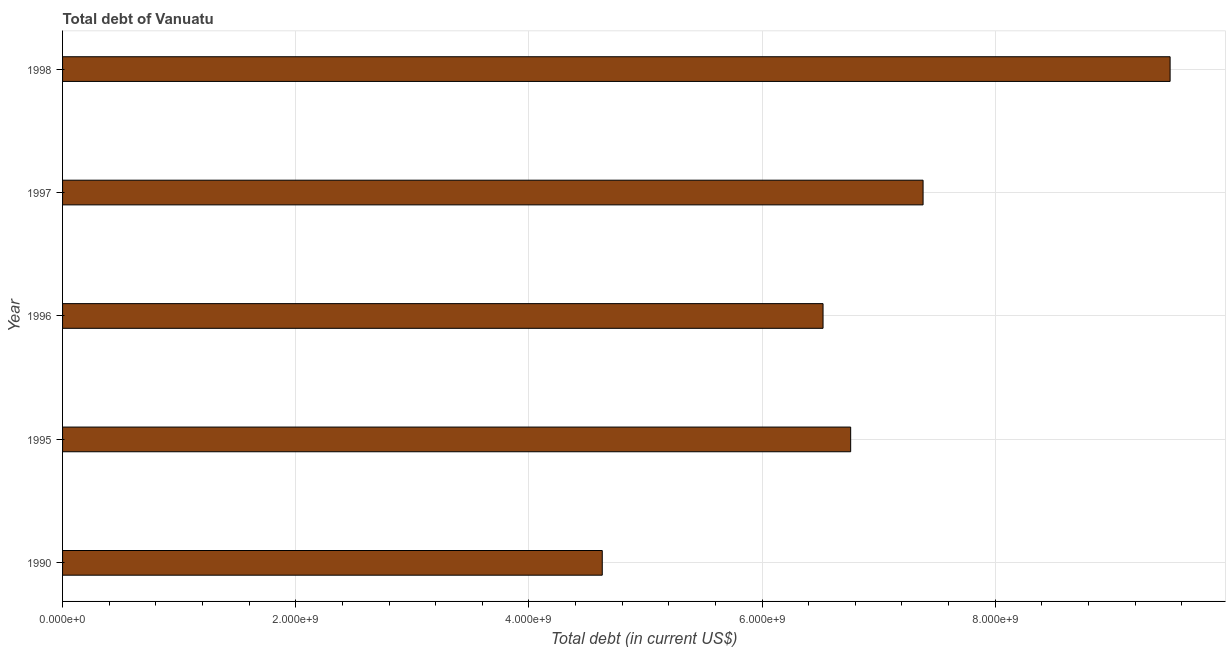Does the graph contain any zero values?
Your response must be concise. No. Does the graph contain grids?
Offer a very short reply. Yes. What is the title of the graph?
Make the answer very short. Total debt of Vanuatu. What is the label or title of the X-axis?
Provide a succinct answer. Total debt (in current US$). What is the total debt in 1997?
Keep it short and to the point. 7.38e+09. Across all years, what is the maximum total debt?
Offer a very short reply. 9.50e+09. Across all years, what is the minimum total debt?
Offer a very short reply. 4.63e+09. What is the sum of the total debt?
Provide a short and direct response. 3.48e+1. What is the difference between the total debt in 1995 and 1998?
Your answer should be very brief. -2.74e+09. What is the average total debt per year?
Your answer should be very brief. 6.96e+09. What is the median total debt?
Provide a short and direct response. 6.76e+09. What is the ratio of the total debt in 1996 to that in 1998?
Your answer should be very brief. 0.69. Is the total debt in 1997 less than that in 1998?
Give a very brief answer. Yes. Is the difference between the total debt in 1996 and 1998 greater than the difference between any two years?
Your response must be concise. No. What is the difference between the highest and the second highest total debt?
Your answer should be compact. 2.12e+09. What is the difference between the highest and the lowest total debt?
Your answer should be very brief. 4.87e+09. In how many years, is the total debt greater than the average total debt taken over all years?
Offer a very short reply. 2. How many bars are there?
Your answer should be very brief. 5. What is the difference between two consecutive major ticks on the X-axis?
Provide a short and direct response. 2.00e+09. Are the values on the major ticks of X-axis written in scientific E-notation?
Provide a succinct answer. Yes. What is the Total debt (in current US$) of 1990?
Make the answer very short. 4.63e+09. What is the Total debt (in current US$) in 1995?
Offer a terse response. 6.76e+09. What is the Total debt (in current US$) in 1996?
Ensure brevity in your answer.  6.52e+09. What is the Total debt (in current US$) in 1997?
Provide a short and direct response. 7.38e+09. What is the Total debt (in current US$) in 1998?
Make the answer very short. 9.50e+09. What is the difference between the Total debt (in current US$) in 1990 and 1995?
Give a very brief answer. -2.13e+09. What is the difference between the Total debt (in current US$) in 1990 and 1996?
Your answer should be compact. -1.89e+09. What is the difference between the Total debt (in current US$) in 1990 and 1997?
Your response must be concise. -2.75e+09. What is the difference between the Total debt (in current US$) in 1990 and 1998?
Your answer should be compact. -4.87e+09. What is the difference between the Total debt (in current US$) in 1995 and 1996?
Make the answer very short. 2.37e+08. What is the difference between the Total debt (in current US$) in 1995 and 1997?
Give a very brief answer. -6.21e+08. What is the difference between the Total debt (in current US$) in 1995 and 1998?
Give a very brief answer. -2.74e+09. What is the difference between the Total debt (in current US$) in 1996 and 1997?
Give a very brief answer. -8.58e+08. What is the difference between the Total debt (in current US$) in 1996 and 1998?
Offer a very short reply. -2.98e+09. What is the difference between the Total debt (in current US$) in 1997 and 1998?
Offer a terse response. -2.12e+09. What is the ratio of the Total debt (in current US$) in 1990 to that in 1995?
Provide a short and direct response. 0.69. What is the ratio of the Total debt (in current US$) in 1990 to that in 1996?
Offer a very short reply. 0.71. What is the ratio of the Total debt (in current US$) in 1990 to that in 1997?
Provide a short and direct response. 0.63. What is the ratio of the Total debt (in current US$) in 1990 to that in 1998?
Your answer should be compact. 0.49. What is the ratio of the Total debt (in current US$) in 1995 to that in 1996?
Your response must be concise. 1.04. What is the ratio of the Total debt (in current US$) in 1995 to that in 1997?
Keep it short and to the point. 0.92. What is the ratio of the Total debt (in current US$) in 1995 to that in 1998?
Keep it short and to the point. 0.71. What is the ratio of the Total debt (in current US$) in 1996 to that in 1997?
Provide a short and direct response. 0.88. What is the ratio of the Total debt (in current US$) in 1996 to that in 1998?
Provide a succinct answer. 0.69. What is the ratio of the Total debt (in current US$) in 1997 to that in 1998?
Give a very brief answer. 0.78. 